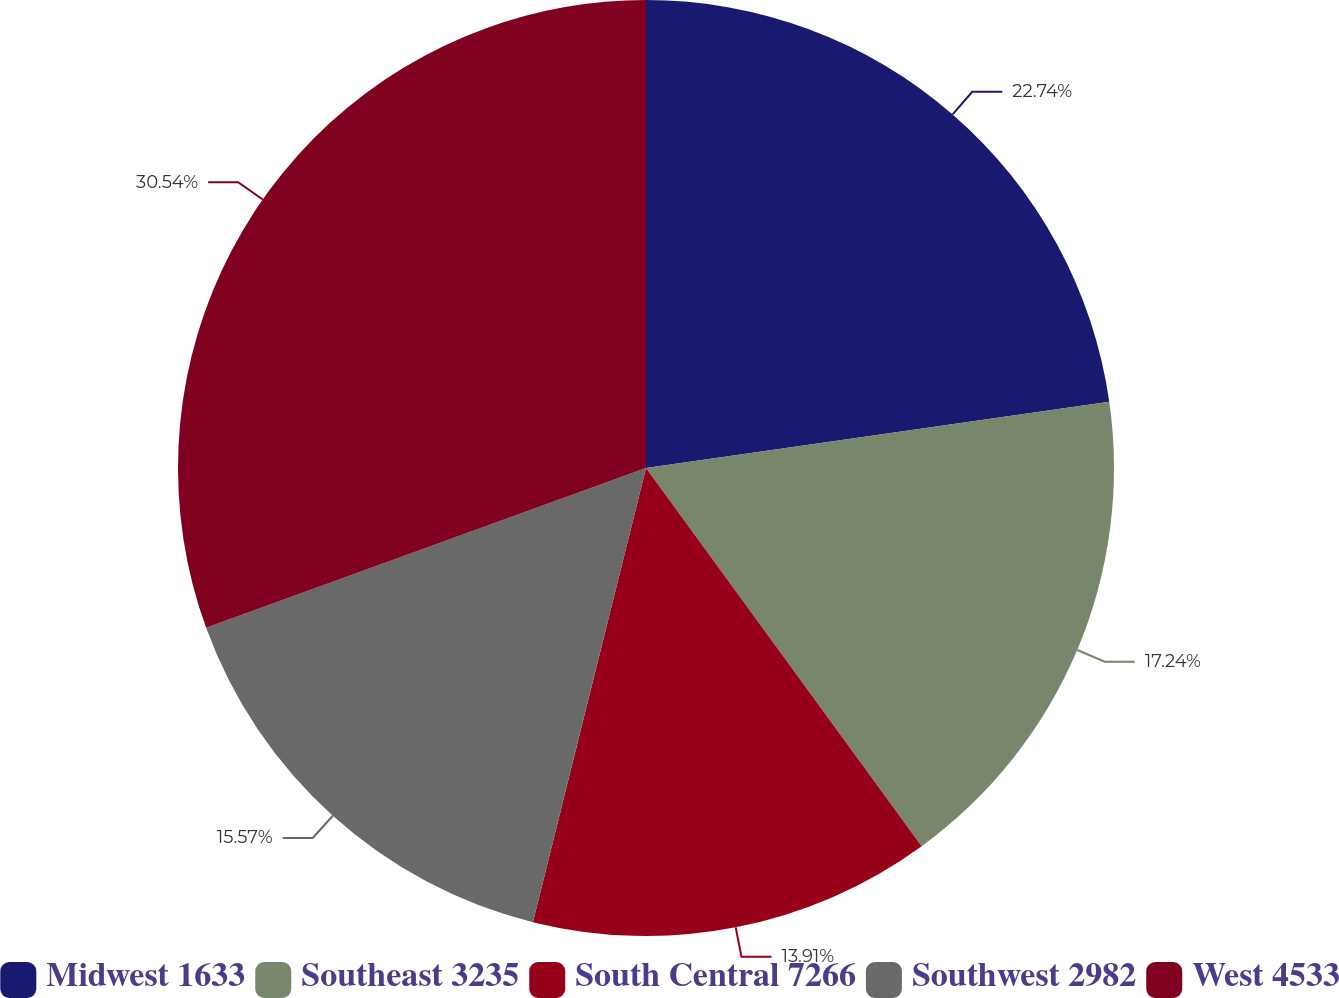Convert chart. <chart><loc_0><loc_0><loc_500><loc_500><pie_chart><fcel>Midwest 1633<fcel>Southeast 3235<fcel>South Central 7266<fcel>Southwest 2982<fcel>West 4533<nl><fcel>22.74%<fcel>17.24%<fcel>13.91%<fcel>15.57%<fcel>30.55%<nl></chart> 